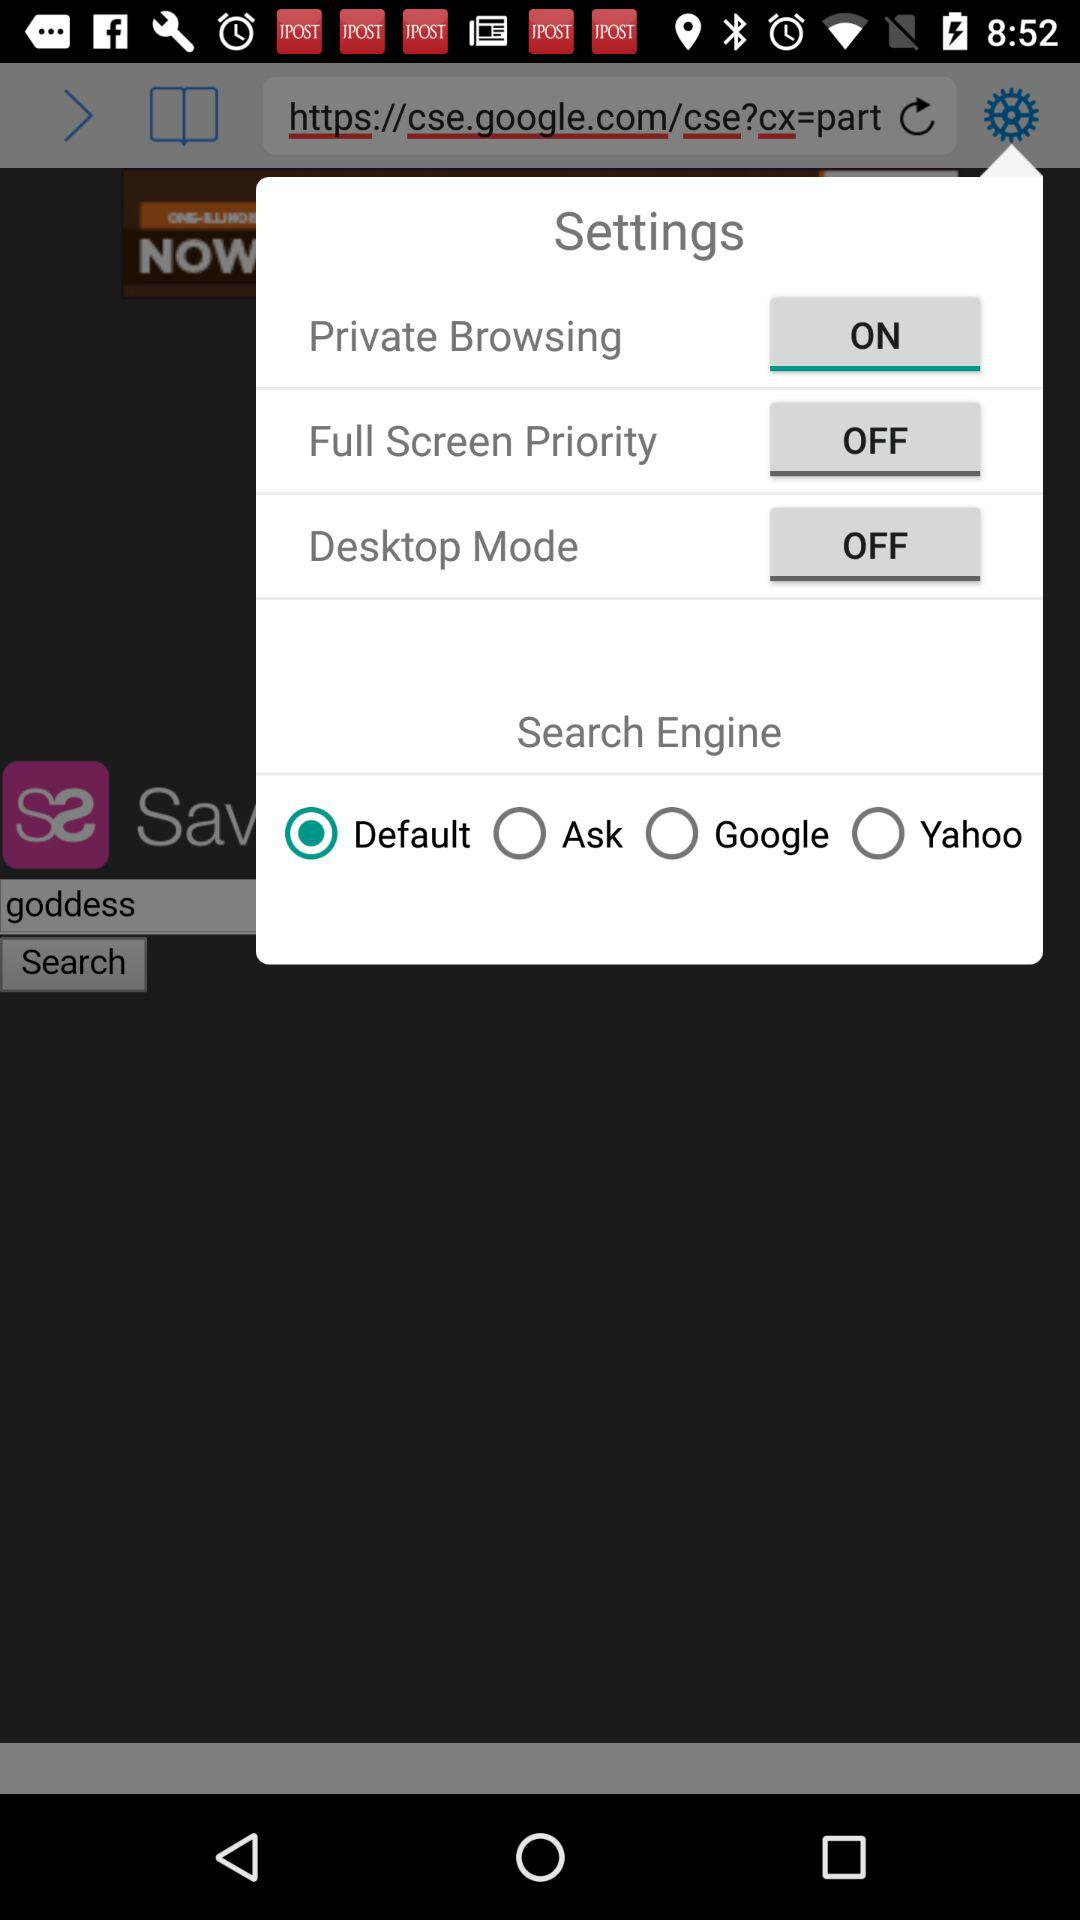What are the search engines that I can select? The search engines are "Default", "Ask", "Google" and "Yahoo". 